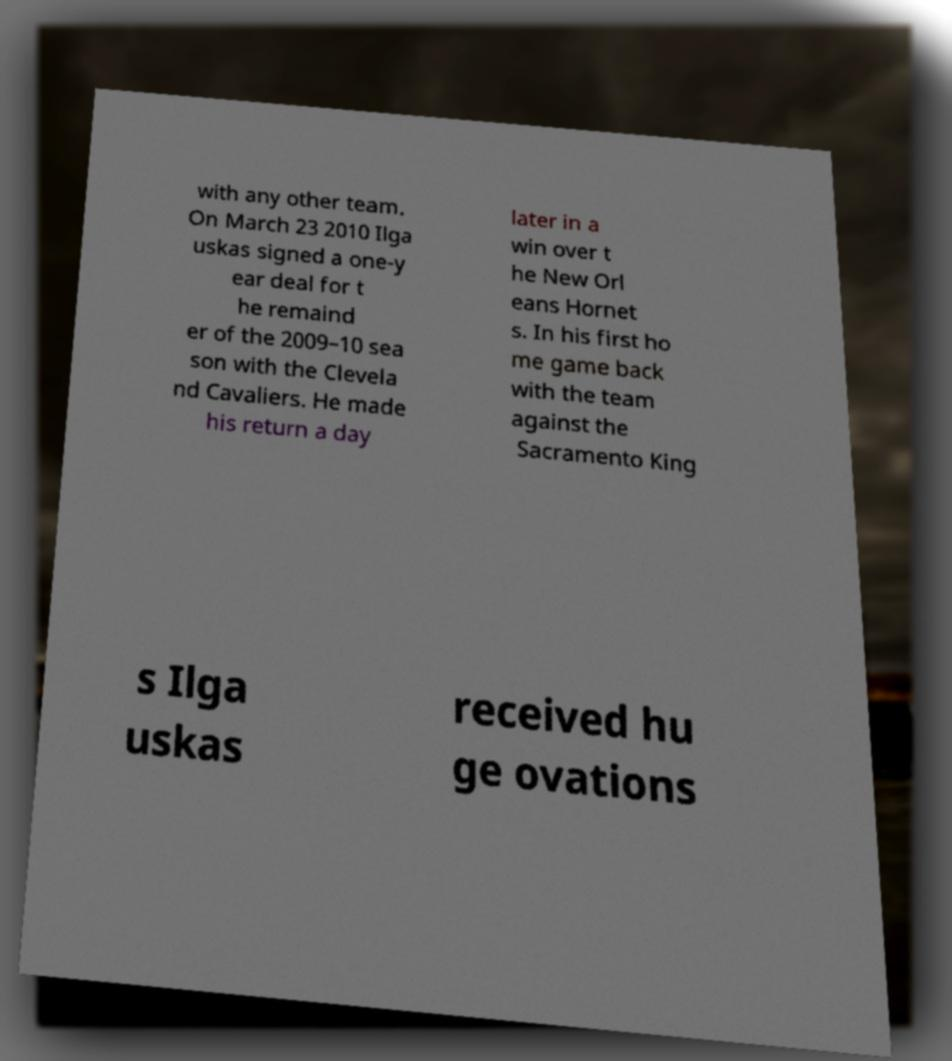Could you extract and type out the text from this image? with any other team. On March 23 2010 Ilga uskas signed a one-y ear deal for t he remaind er of the 2009–10 sea son with the Clevela nd Cavaliers. He made his return a day later in a win over t he New Orl eans Hornet s. In his first ho me game back with the team against the Sacramento King s Ilga uskas received hu ge ovations 